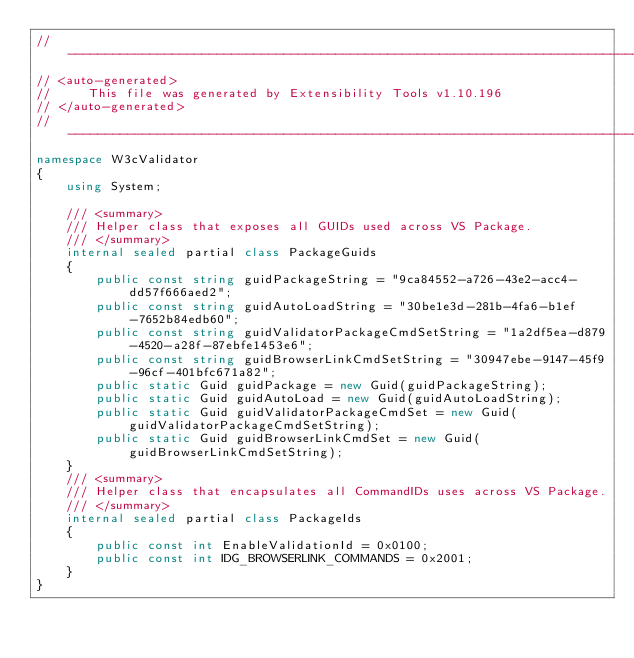Convert code to text. <code><loc_0><loc_0><loc_500><loc_500><_C#_>// ------------------------------------------------------------------------------
// <auto-generated>
//     This file was generated by Extensibility Tools v1.10.196
// </auto-generated>
// ------------------------------------------------------------------------------
namespace W3cValidator
{
    using System;
    
    /// <summary>
    /// Helper class that exposes all GUIDs used across VS Package.
    /// </summary>
    internal sealed partial class PackageGuids
    {
        public const string guidPackageString = "9ca84552-a726-43e2-acc4-dd57f666aed2";
        public const string guidAutoLoadString = "30be1e3d-281b-4fa6-b1ef-7652b84edb60";
        public const string guidValidatorPackageCmdSetString = "1a2df5ea-d879-4520-a28f-87ebfe1453e6";
        public const string guidBrowserLinkCmdSetString = "30947ebe-9147-45f9-96cf-401bfc671a82";
        public static Guid guidPackage = new Guid(guidPackageString);
        public static Guid guidAutoLoad = new Guid(guidAutoLoadString);
        public static Guid guidValidatorPackageCmdSet = new Guid(guidValidatorPackageCmdSetString);
        public static Guid guidBrowserLinkCmdSet = new Guid(guidBrowserLinkCmdSetString);
    }
    /// <summary>
    /// Helper class that encapsulates all CommandIDs uses across VS Package.
    /// </summary>
    internal sealed partial class PackageIds
    {
        public const int EnableValidationId = 0x0100;
        public const int IDG_BROWSERLINK_COMMANDS = 0x2001;
    }
}
</code> 